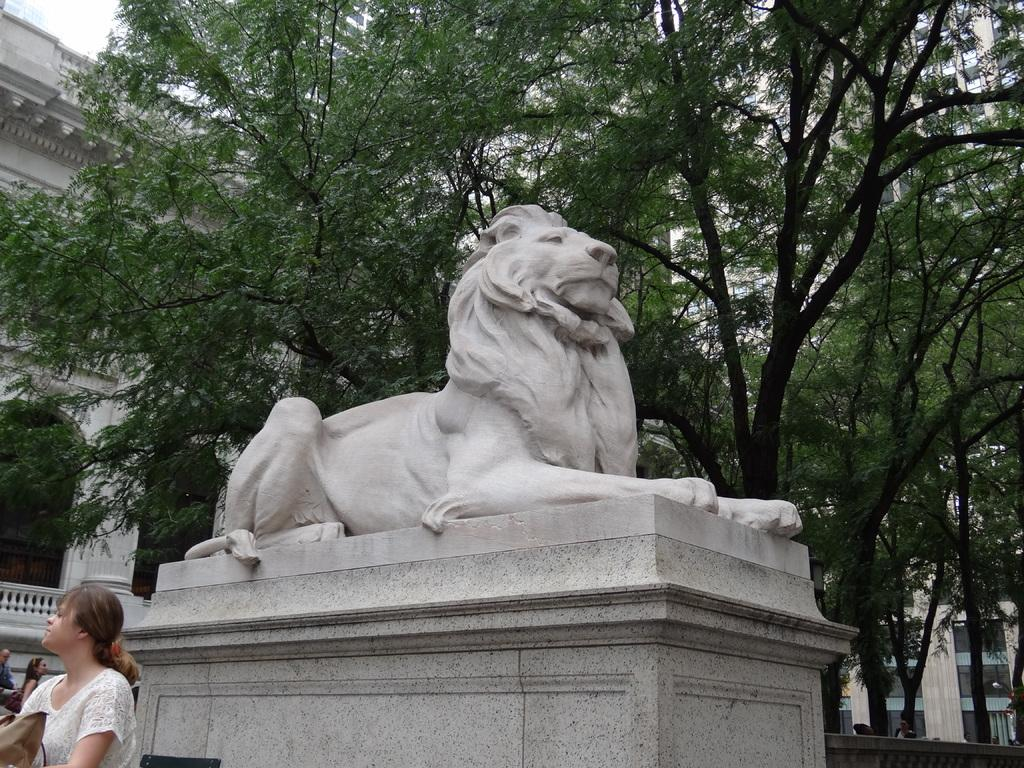What is the main subject of the statue in the image? There is a statue of an animal in the image. How can you describe the people in the image? There are people with different color dresses in the image. What can be seen in the background of the image? There are many trees and buildings in the background of the image, as well as the sky. What type of expansion is being demonstrated by the dog in the image? There is no dog present in the image; it features a statue of an animal. What is the basin used for in the image? There is no basin present in the image. 